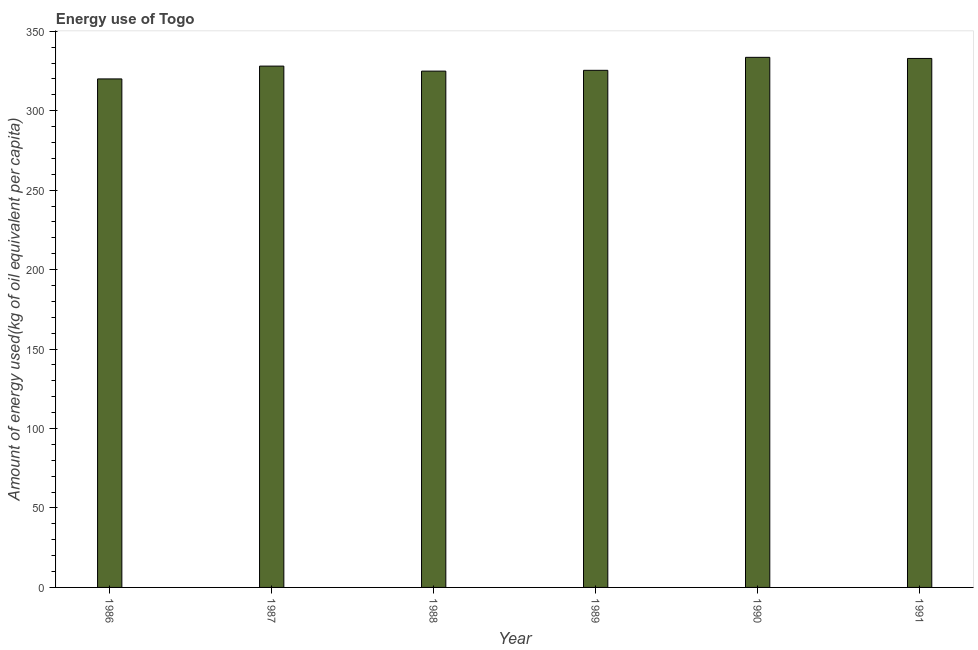What is the title of the graph?
Offer a terse response. Energy use of Togo. What is the label or title of the Y-axis?
Provide a short and direct response. Amount of energy used(kg of oil equivalent per capita). What is the amount of energy used in 1989?
Offer a terse response. 325.4. Across all years, what is the maximum amount of energy used?
Offer a terse response. 333.58. Across all years, what is the minimum amount of energy used?
Give a very brief answer. 320. In which year was the amount of energy used maximum?
Provide a short and direct response. 1990. What is the sum of the amount of energy used?
Your response must be concise. 1964.82. What is the difference between the amount of energy used in 1988 and 1991?
Make the answer very short. -7.97. What is the average amount of energy used per year?
Offer a very short reply. 327.47. What is the median amount of energy used?
Provide a succinct answer. 326.73. What is the ratio of the amount of energy used in 1986 to that in 1990?
Offer a terse response. 0.96. Is the difference between the amount of energy used in 1988 and 1989 greater than the difference between any two years?
Ensure brevity in your answer.  No. What is the difference between the highest and the second highest amount of energy used?
Your answer should be very brief. 0.7. Is the sum of the amount of energy used in 1987 and 1988 greater than the maximum amount of energy used across all years?
Give a very brief answer. Yes. What is the difference between the highest and the lowest amount of energy used?
Offer a very short reply. 13.58. How many bars are there?
Offer a terse response. 6. Are all the bars in the graph horizontal?
Keep it short and to the point. No. How many years are there in the graph?
Offer a terse response. 6. What is the difference between two consecutive major ticks on the Y-axis?
Your answer should be very brief. 50. What is the Amount of energy used(kg of oil equivalent per capita) in 1986?
Provide a succinct answer. 320. What is the Amount of energy used(kg of oil equivalent per capita) in 1987?
Provide a short and direct response. 328.06. What is the Amount of energy used(kg of oil equivalent per capita) in 1988?
Provide a succinct answer. 324.9. What is the Amount of energy used(kg of oil equivalent per capita) of 1989?
Offer a very short reply. 325.4. What is the Amount of energy used(kg of oil equivalent per capita) of 1990?
Offer a terse response. 333.58. What is the Amount of energy used(kg of oil equivalent per capita) in 1991?
Provide a succinct answer. 332.87. What is the difference between the Amount of energy used(kg of oil equivalent per capita) in 1986 and 1987?
Your answer should be very brief. -8.07. What is the difference between the Amount of energy used(kg of oil equivalent per capita) in 1986 and 1988?
Give a very brief answer. -4.91. What is the difference between the Amount of energy used(kg of oil equivalent per capita) in 1986 and 1989?
Give a very brief answer. -5.41. What is the difference between the Amount of energy used(kg of oil equivalent per capita) in 1986 and 1990?
Ensure brevity in your answer.  -13.58. What is the difference between the Amount of energy used(kg of oil equivalent per capita) in 1986 and 1991?
Give a very brief answer. -12.88. What is the difference between the Amount of energy used(kg of oil equivalent per capita) in 1987 and 1988?
Make the answer very short. 3.16. What is the difference between the Amount of energy used(kg of oil equivalent per capita) in 1987 and 1989?
Offer a terse response. 2.66. What is the difference between the Amount of energy used(kg of oil equivalent per capita) in 1987 and 1990?
Your answer should be very brief. -5.52. What is the difference between the Amount of energy used(kg of oil equivalent per capita) in 1987 and 1991?
Offer a terse response. -4.81. What is the difference between the Amount of energy used(kg of oil equivalent per capita) in 1988 and 1989?
Provide a short and direct response. -0.5. What is the difference between the Amount of energy used(kg of oil equivalent per capita) in 1988 and 1990?
Provide a short and direct response. -8.68. What is the difference between the Amount of energy used(kg of oil equivalent per capita) in 1988 and 1991?
Your response must be concise. -7.97. What is the difference between the Amount of energy used(kg of oil equivalent per capita) in 1989 and 1990?
Offer a very short reply. -8.17. What is the difference between the Amount of energy used(kg of oil equivalent per capita) in 1989 and 1991?
Your answer should be compact. -7.47. What is the difference between the Amount of energy used(kg of oil equivalent per capita) in 1990 and 1991?
Your answer should be compact. 0.7. What is the ratio of the Amount of energy used(kg of oil equivalent per capita) in 1986 to that in 1987?
Offer a terse response. 0.97. What is the ratio of the Amount of energy used(kg of oil equivalent per capita) in 1986 to that in 1988?
Offer a very short reply. 0.98. What is the ratio of the Amount of energy used(kg of oil equivalent per capita) in 1986 to that in 1989?
Provide a short and direct response. 0.98. What is the ratio of the Amount of energy used(kg of oil equivalent per capita) in 1986 to that in 1990?
Ensure brevity in your answer.  0.96. What is the ratio of the Amount of energy used(kg of oil equivalent per capita) in 1987 to that in 1989?
Your answer should be very brief. 1.01. What is the ratio of the Amount of energy used(kg of oil equivalent per capita) in 1988 to that in 1989?
Offer a very short reply. 1. What is the ratio of the Amount of energy used(kg of oil equivalent per capita) in 1988 to that in 1991?
Your response must be concise. 0.98. What is the ratio of the Amount of energy used(kg of oil equivalent per capita) in 1989 to that in 1990?
Your answer should be compact. 0.97. What is the ratio of the Amount of energy used(kg of oil equivalent per capita) in 1989 to that in 1991?
Make the answer very short. 0.98. 